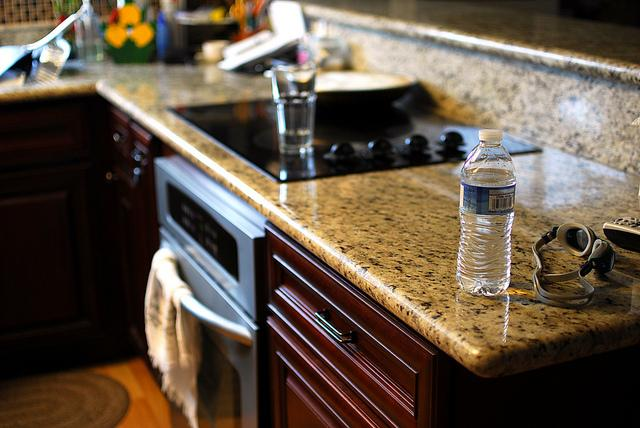The item next to the water bottle is usually used in what setting? swimming 